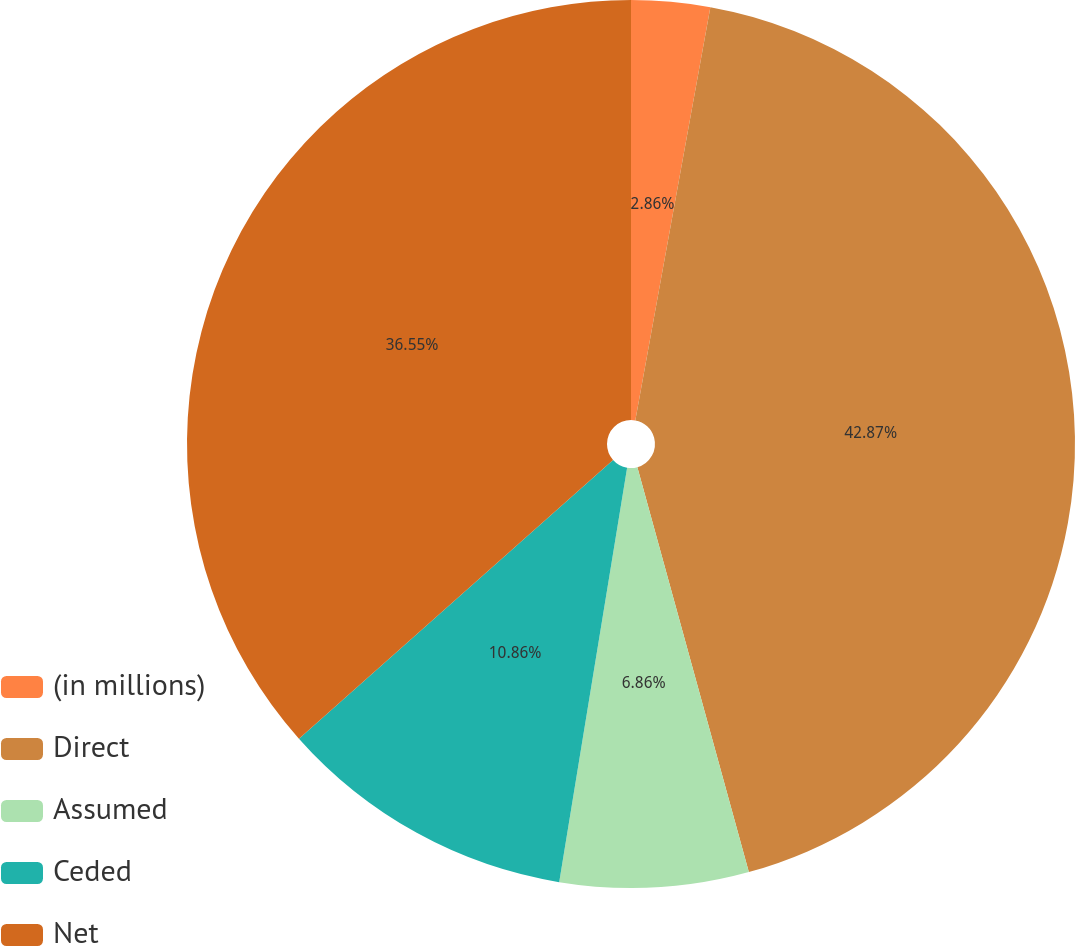<chart> <loc_0><loc_0><loc_500><loc_500><pie_chart><fcel>(in millions)<fcel>Direct<fcel>Assumed<fcel>Ceded<fcel>Net<nl><fcel>2.86%<fcel>42.86%<fcel>6.86%<fcel>10.86%<fcel>36.55%<nl></chart> 